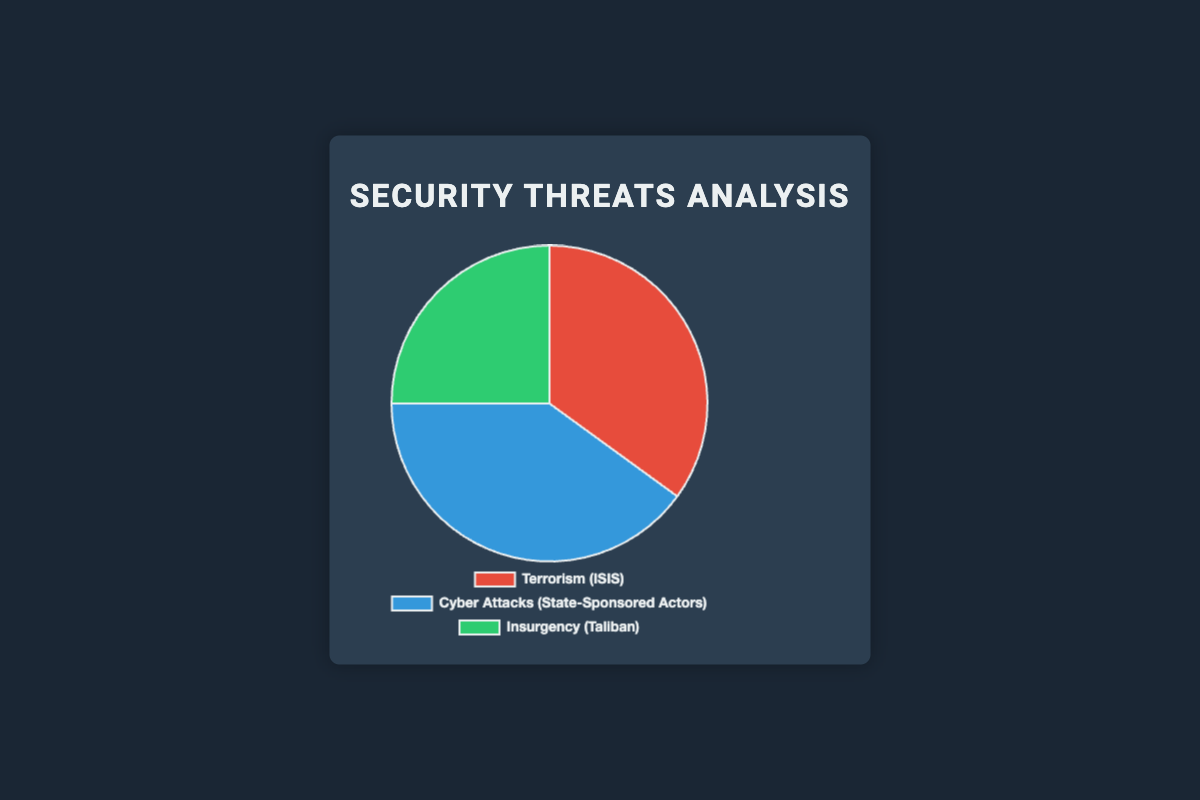What are the three types of security threats represented in the pie chart? The pie chart has three sectors, each labeled as follows: Terrorism (ISIS), Cyber Attacks (State-Sponsored Actors), and Insurgency (Taliban).
Answer: Terrorism, Cyber Attacks, Insurgency Which threat has the highest percentage? The sector labeled 'Cyber Attacks (State-Sponsored Actors)' occupies the largest portion of the pie chart, indicating it has the highest percentage.
Answer: Cyber Attacks Which threat is depicted in green color? By observing the colors of the pie chart, the green sector is labeled as 'Insurgency (Taliban)'.
Answer: Insurgency What is the percentage difference between the threat mostly associated with Terrorism and Cyber Attacks? The percentage for Terrorism (ISIS) is 35%, and for Cyber Attacks (State-Sponsored Actors) is 40%. The difference is 40% - 35% = 5%.
Answer: 5% What is the combined percentage of Terrorism and Insurgency? The percentage for Terrorism (ISIS) is 35%, and for Insurgency (Taliban) is 25%. The combined percentage is 35% + 25% = 60%.
Answer: 60% Arrange the security threats in descending order of their percentages. The percentages are 40% for Cyber Attacks, 35% for Terrorism, and 25% for Insurgency. Sorting them in descending order gives: Cyber Attacks, Terrorism, Insurgency.
Answer: Cyber Attacks, Terrorism, Insurgency What percentage of the threats does not fall under Cyber Attacks? The pie chart indicates that Cyber Attacks (State-Sponsored Actors) accounts for 40%. Therefore, the percentage that does not fall under Cyber Attacks is 100% - 40% = 60%.
Answer: 60% Compare the percentages of Insurgency and Terrorism. Which one is greater and by how much? The percentage for Insurgency (Taliban) is 25%, and for Terrorism (ISIS) is 35%. Terrorism is greater by 35% - 25% = 10%.
Answer: Terrorism, by 10% What is the average percentage of the three threats presented? Adding the percentages of Terrorism (35%), Cyber Attacks (40%), and Insurgency (25%) gives a total of 100%. The average percentage is 100% / 3 = 33.33%.
Answer: 33.33% Which threat is depicted in red color? By observing the colors of the pie chart, the red sector is labeled as 'Terrorism (ISIS)'.
Answer: Terrorism 